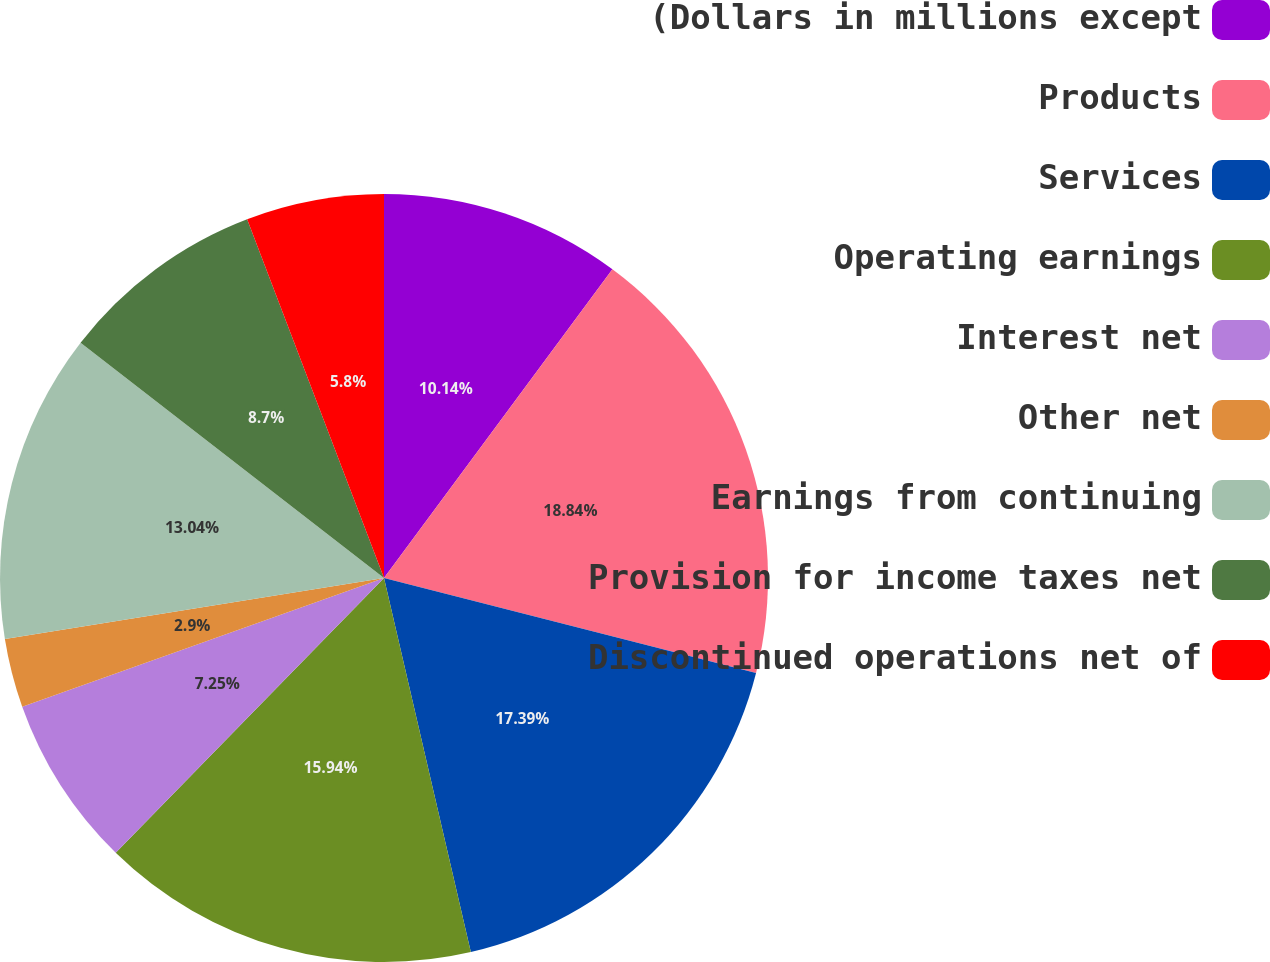Convert chart. <chart><loc_0><loc_0><loc_500><loc_500><pie_chart><fcel>(Dollars in millions except<fcel>Products<fcel>Services<fcel>Operating earnings<fcel>Interest net<fcel>Other net<fcel>Earnings from continuing<fcel>Provision for income taxes net<fcel>Discontinued operations net of<nl><fcel>10.14%<fcel>18.84%<fcel>17.39%<fcel>15.94%<fcel>7.25%<fcel>2.9%<fcel>13.04%<fcel>8.7%<fcel>5.8%<nl></chart> 